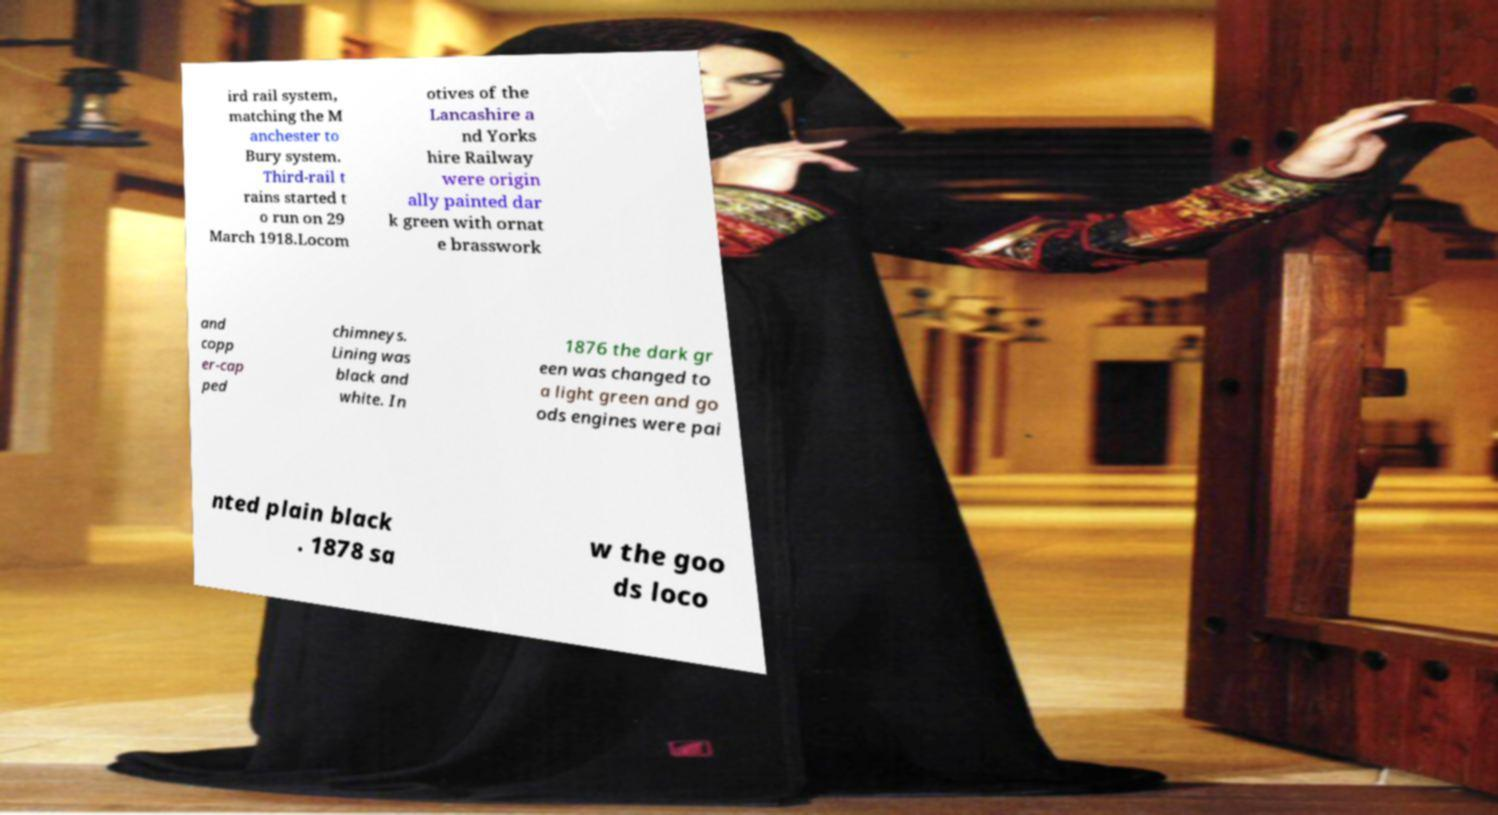Could you extract and type out the text from this image? ird rail system, matching the M anchester to Bury system. Third-rail t rains started t o run on 29 March 1918.Locom otives of the Lancashire a nd Yorks hire Railway were origin ally painted dar k green with ornat e brasswork and copp er-cap ped chimneys. Lining was black and white. In 1876 the dark gr een was changed to a light green and go ods engines were pai nted plain black . 1878 sa w the goo ds loco 